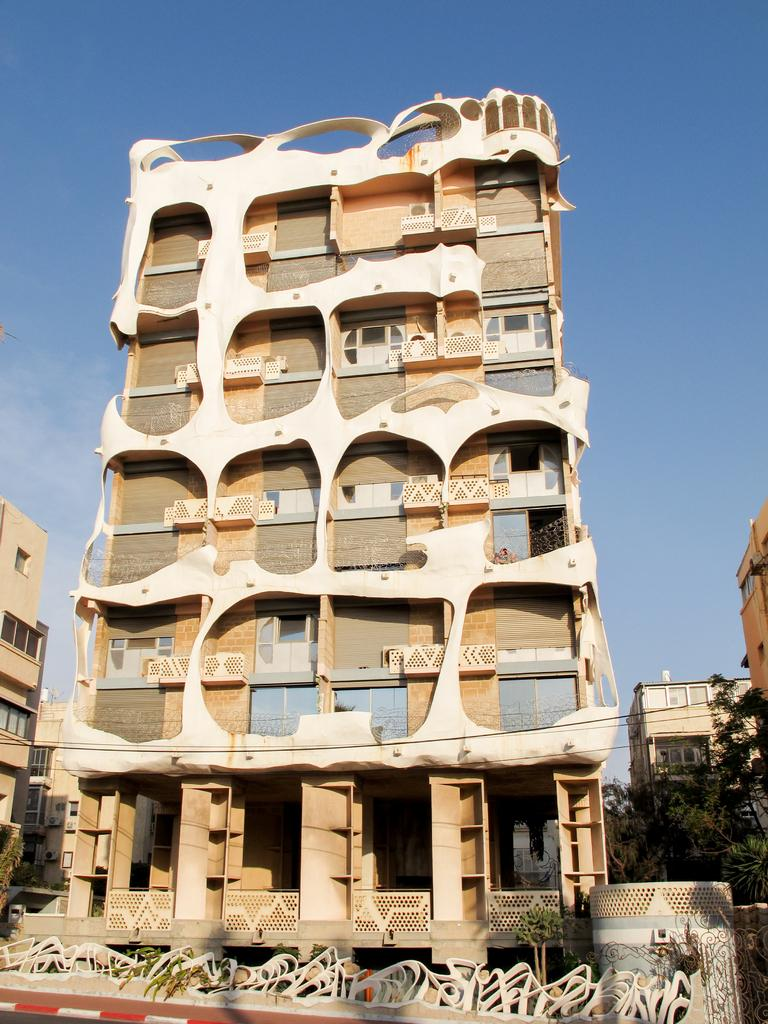What type of structures can be seen in the image? There are buildings in the image. What natural elements are present in the image? There are trees and plants in the image. What man-made elements can be seen in the image? There are wires in the image. What can be seen in the background of the image? There are clouds and the sky visible in the background of the image. Can you tell me the value of the rat in the park in the image? There is no rat or park present in the image, so it is not possible to determine the value of a rat in the park. 